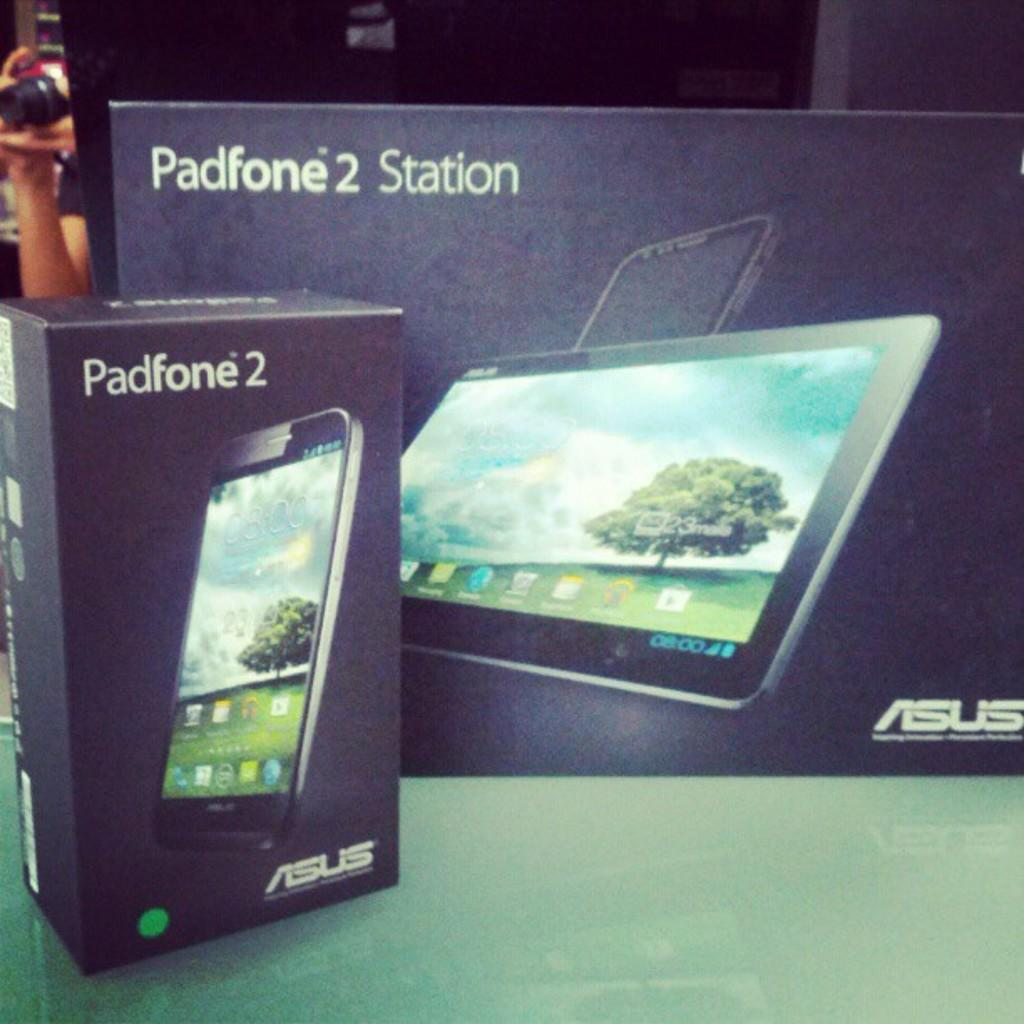How many electronic device boxes are in the image? There are two electronic device boxes in the image. What can be found on the electronic device boxes? There are images on the boxes. What type of metal instrument is being sold in the shop in the image? There is no shop or metal instrument present in the image. 